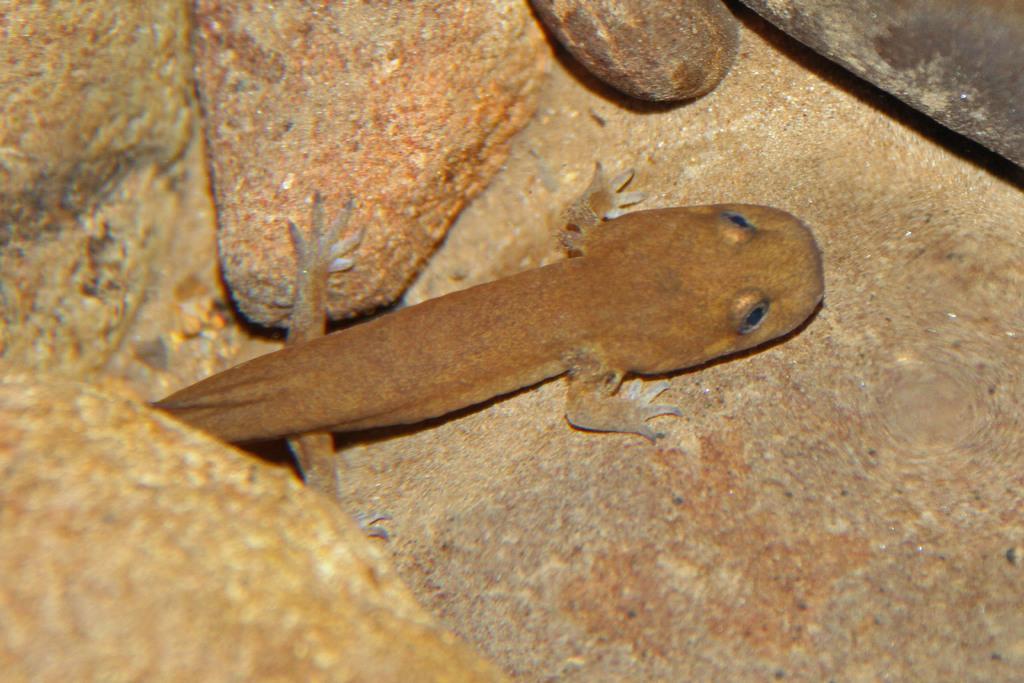How would you summarize this image in a sentence or two? In this image there is a lizard in between the stones. 